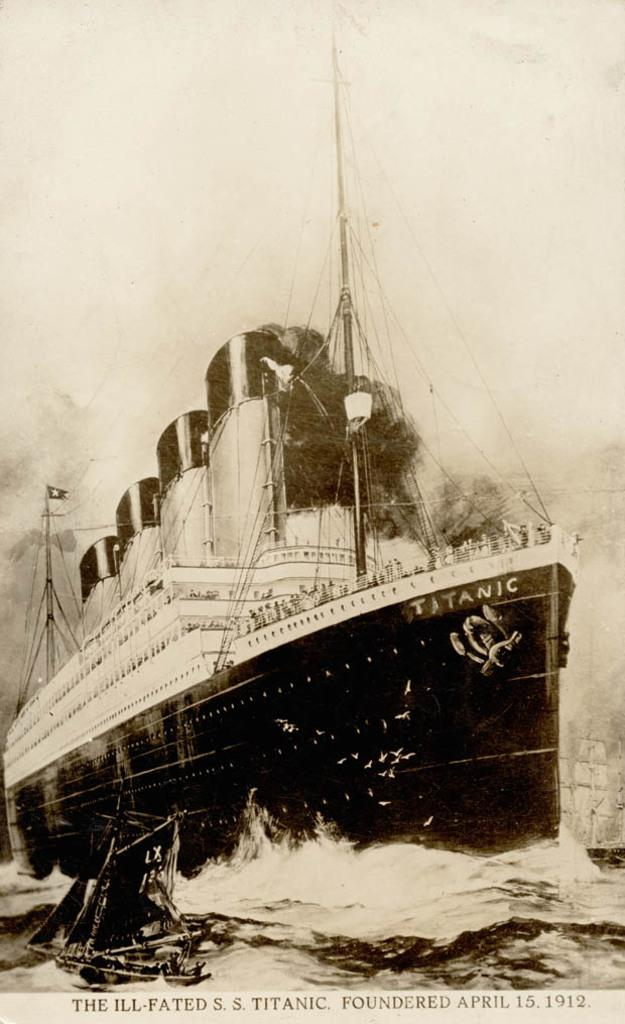What type of visual is depicted in the image? The image is a poster. What is the main subject of the poster? There is a ship in the poster. What is the setting of the poster? There is water in the poster. Is there any text present in the image? Yes, there is text at the bottom of the poster. How many birds are flying over the ship in the poster? There are no birds present in the poster; it only features a ship and water. What type of prose is written at the bottom of the poster? There is no prose present in the poster; it only contains text, which may or may not be prose. 